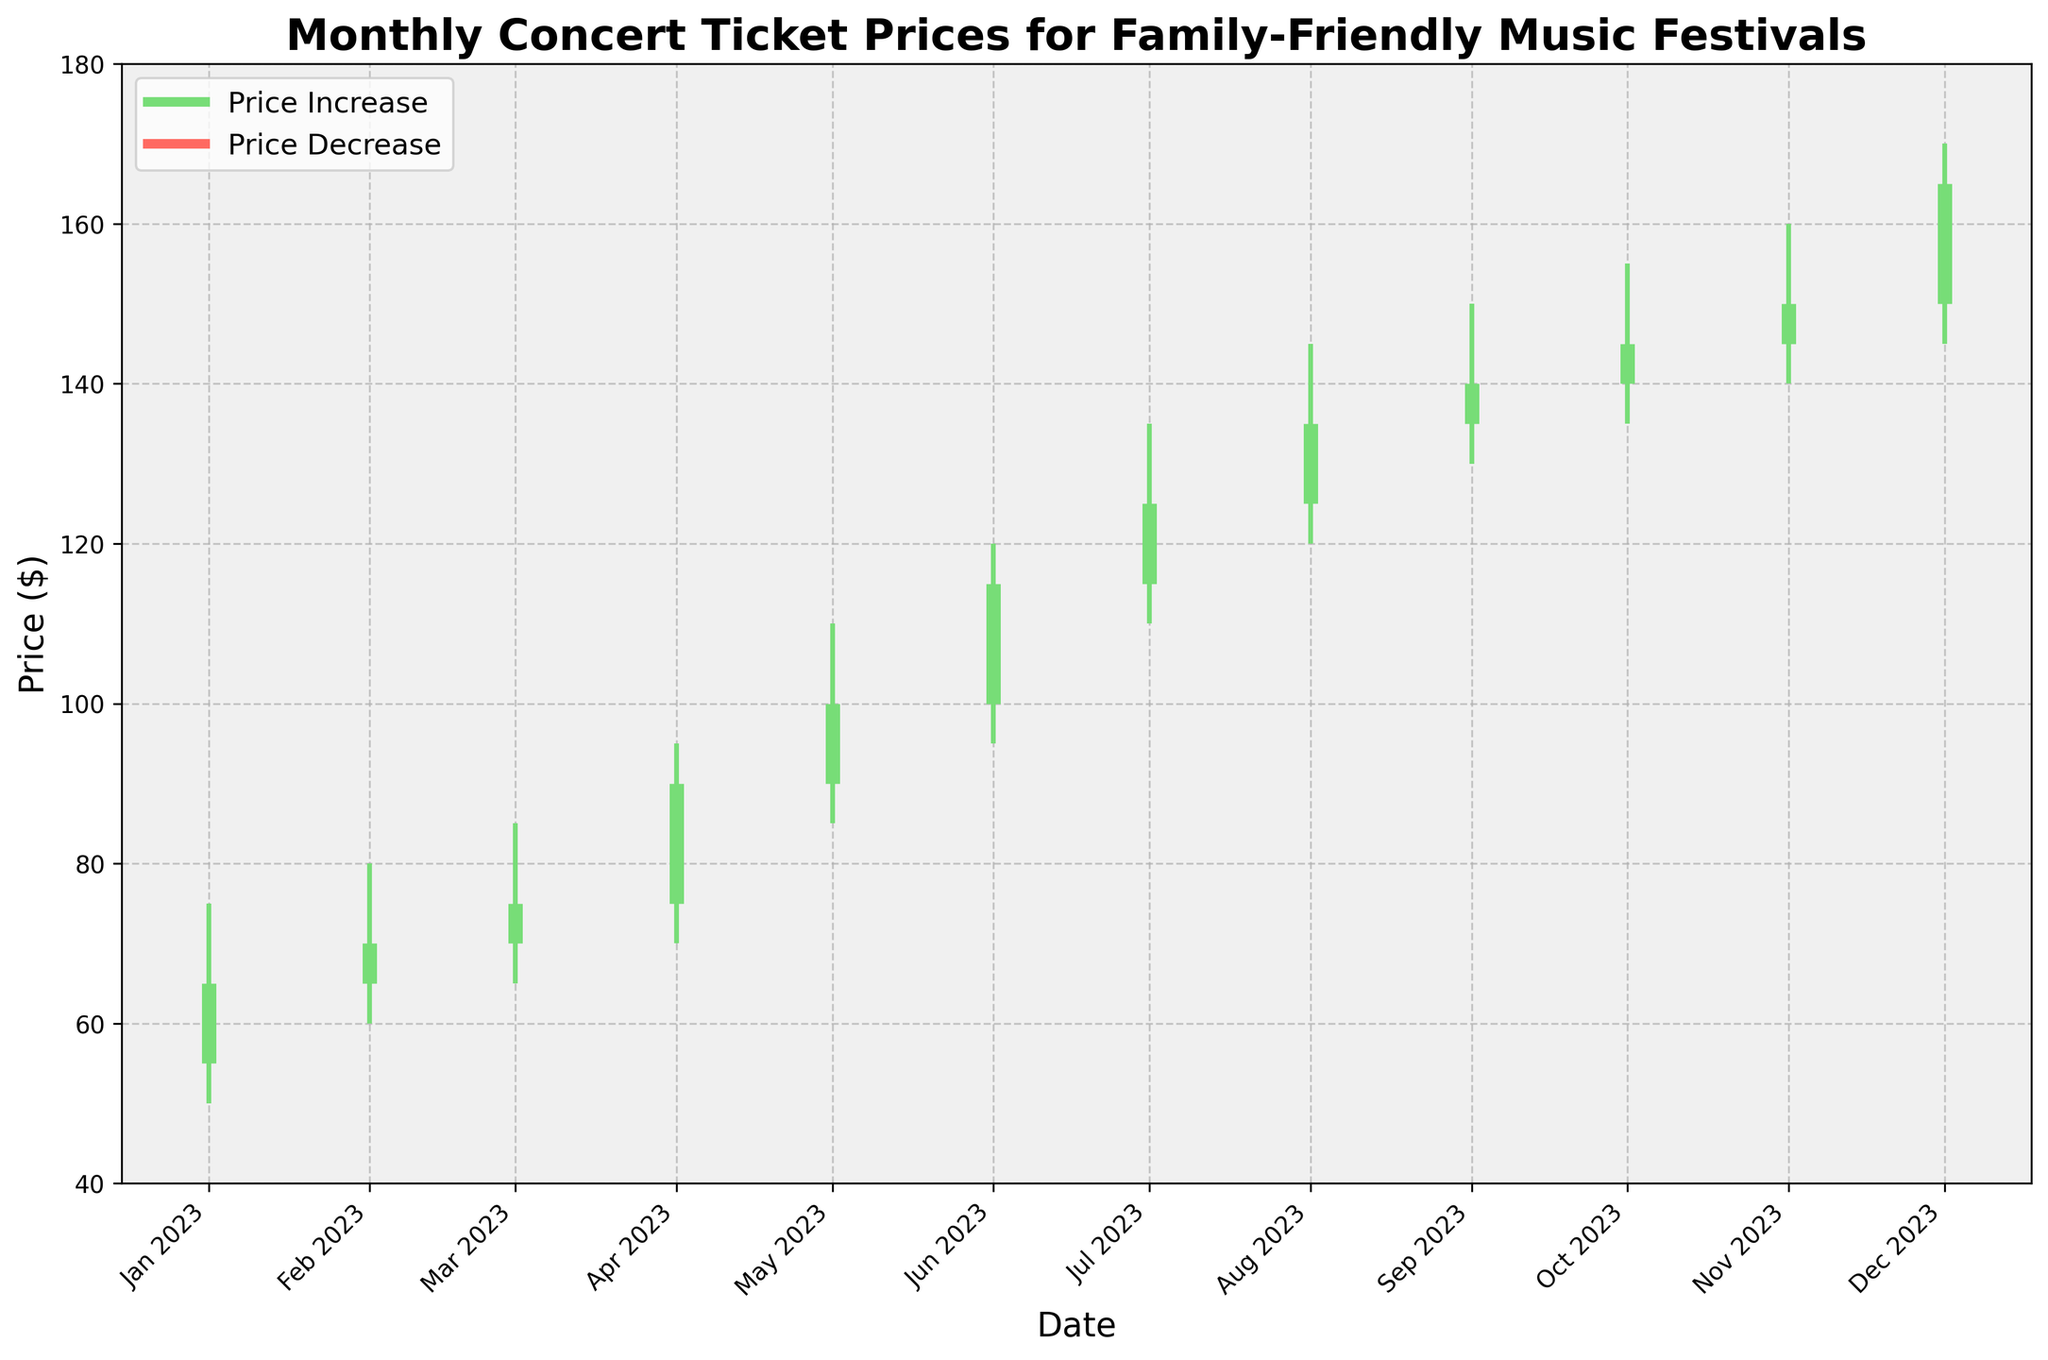What does the title of the chart indicate? The title of the chart indicates the focus of the data being presented, which is the monthly concert ticket prices for family-friendly music festivals.
Answer: Monthly Concert Ticket Prices for Family-Friendly Music Festivals How does the chart represent a month where ticket prices increased from open to close? When ticket prices increased from open to close, the vertical line associated with that month is colored in green, representing a price increase.
Answer: Green lines What was the highest price recorded in August 2023? To determine the highest price for August 2023, refer to the "High" value for that month, which is the top value of the vertical line.
Answer: $145 Which month had the lowest ticket price and what was that price? To find the lowest ticket price, identify the month with the smallest "Low" value on the chart, which appears at the bottom of each vertical line. The lowest price across all months was recorded in January 2023 at $50.
Answer: January 2023, $50 Across which months did the closing price consistently increase? Observing the closing prices from month to month, identify the months where each month's closing price is higher than the previous month's closing price. This occurs consistently from January 2023 to December 2023.
Answer: January to December Which month shows the greatest difference between the highest and the lowest prices? To find the month with the greatest range between the high and low prices, calculate the difference for each month and compare them. April has the greatest difference between $95 (high) and $70 (low), a difference of $25.
Answer: April 2023 Did any month have the same opening and closing prices? Look for any month where the opening price is equal to the closing price, indicating a line with the same start and end point. No such month appears on this chart.
Answer: No What was the price trend from July to September 2023? Analyze the closing prices from July to September. They show an increasing trend: $125 in July, $135 in August, $140 in September.
Answer: Increasing Which month had the largest increase from opening to closing prices? Identify the months where the closing price is significantly higher than the opening price and calculate the differences. August 2023 shows the largest increase, with a difference of $10 (Open: $125, Close: $135).
Answer: August 2023 How many months had their closing prices above $100? Count the number of closing prices that are greater than $100. The months where this occurs are from May to December, making a total of 8 months.
Answer: 8 months 